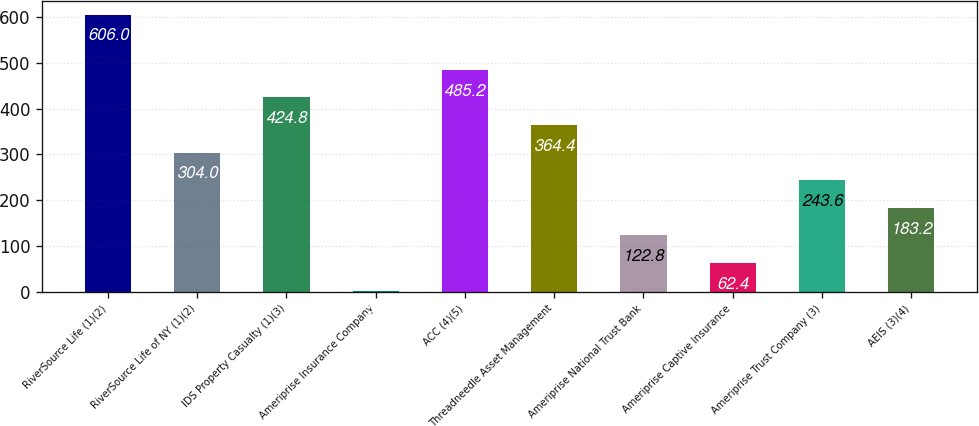Convert chart to OTSL. <chart><loc_0><loc_0><loc_500><loc_500><bar_chart><fcel>RiverSource Life (1)(2)<fcel>RiverSource Life of NY (1)(2)<fcel>IDS Property Casualty (1)(3)<fcel>Ameriprise Insurance Company<fcel>ACC (4)(5)<fcel>Threadneedle Asset Management<fcel>Ameriprise National Trust Bank<fcel>Ameriprise Captive Insurance<fcel>Ameriprise Trust Company (3)<fcel>AEIS (3)(4)<nl><fcel>606<fcel>304<fcel>424.8<fcel>2<fcel>485.2<fcel>364.4<fcel>122.8<fcel>62.4<fcel>243.6<fcel>183.2<nl></chart> 